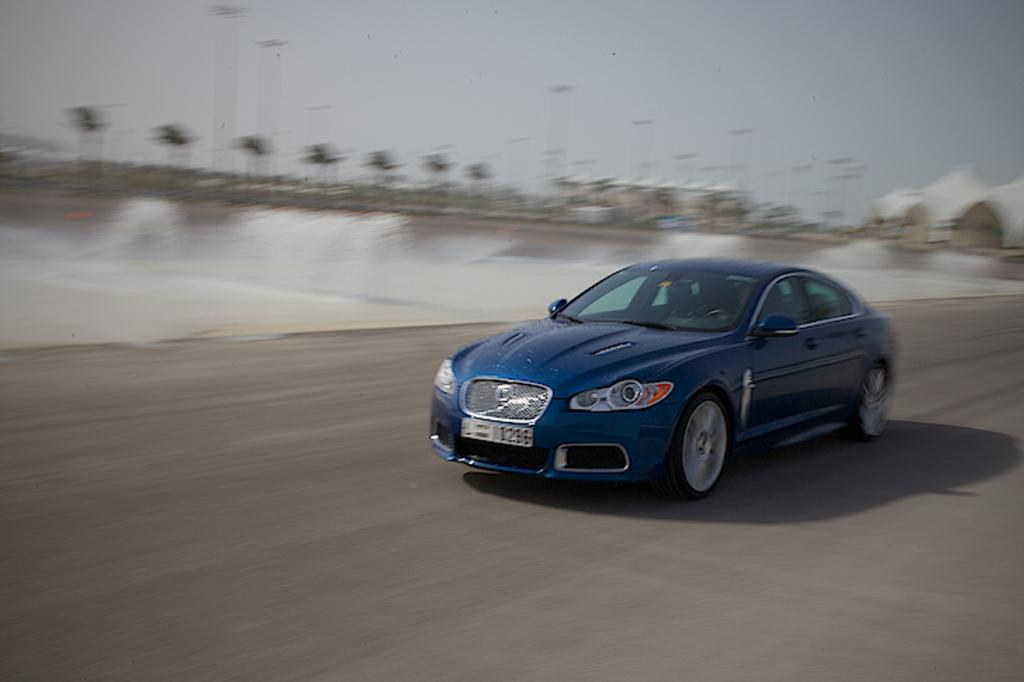What is the main subject of the image? The main subject of the image is a car on the road. What can be seen behind the car? There are trees visible behind the car, as well as blurred objects. What is visible at the top of the image? The sky is visible at the top of the image. How many yams are being used to destroy the car in the image? There are no yams present in the image, nor is there any destruction occurring. 